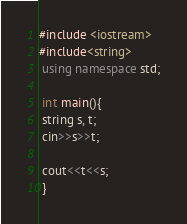Convert code to text. <code><loc_0><loc_0><loc_500><loc_500><_C++_>#include <iostream>
#include<string>
 using namespace std;

 int main(){
 string s, t;
 cin>>s>>t;

 cout<<t<<s;
 }
</code> 